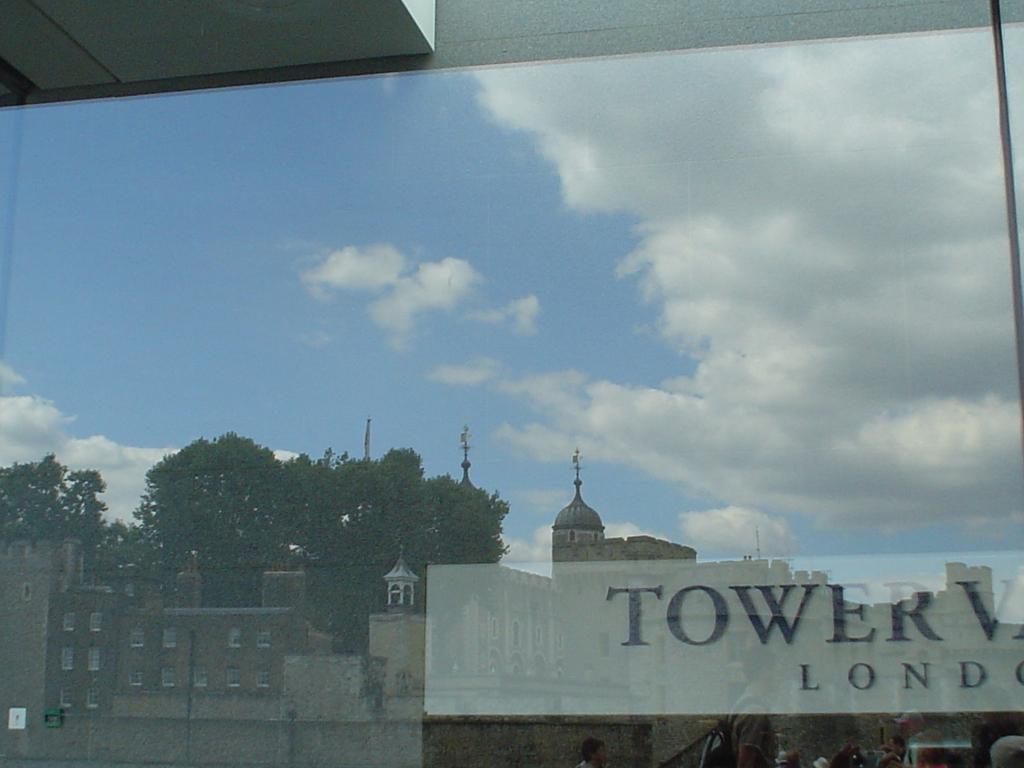Where was this picture taken?
Offer a very short reply. London. 